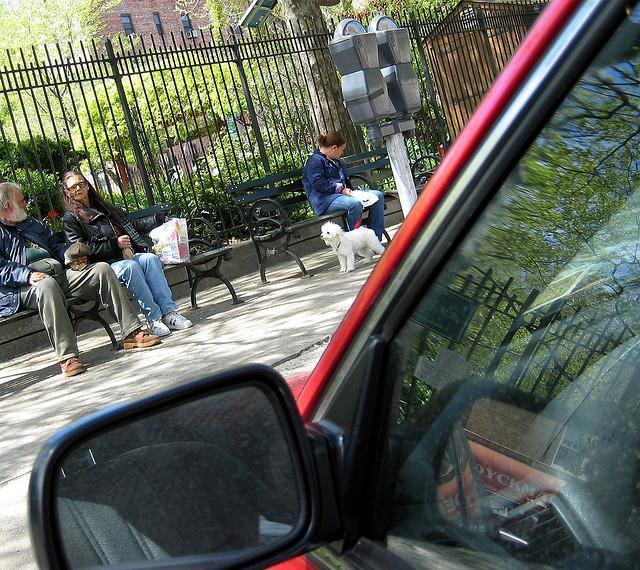How many people are in the photo?
Give a very brief answer. 3. How many benches are visible?
Give a very brief answer. 2. How many parking meters are in the picture?
Give a very brief answer. 2. How many cars are in the photo?
Give a very brief answer. 1. 